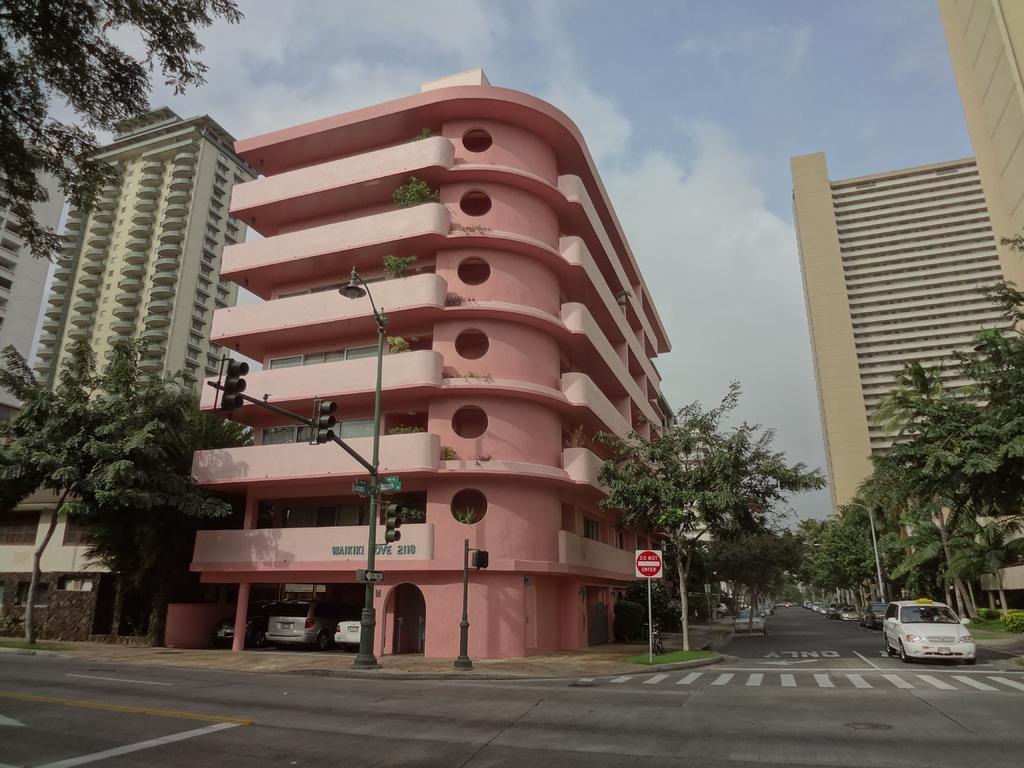How would you summarize this image in a sentence or two? In the foreground of this image, there is the road and a vehicle on it. On the right, there are trees and few buildings. On the left, there are traffic lights to the pole, trees, buildings and the sky and the cloud on the top. In the middle, there is a sign board. 